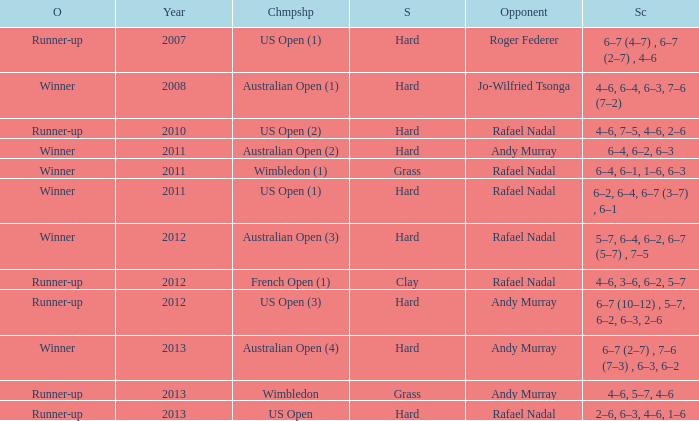What is the outcome of the match with Roger Federer as the opponent? Runner-up. 